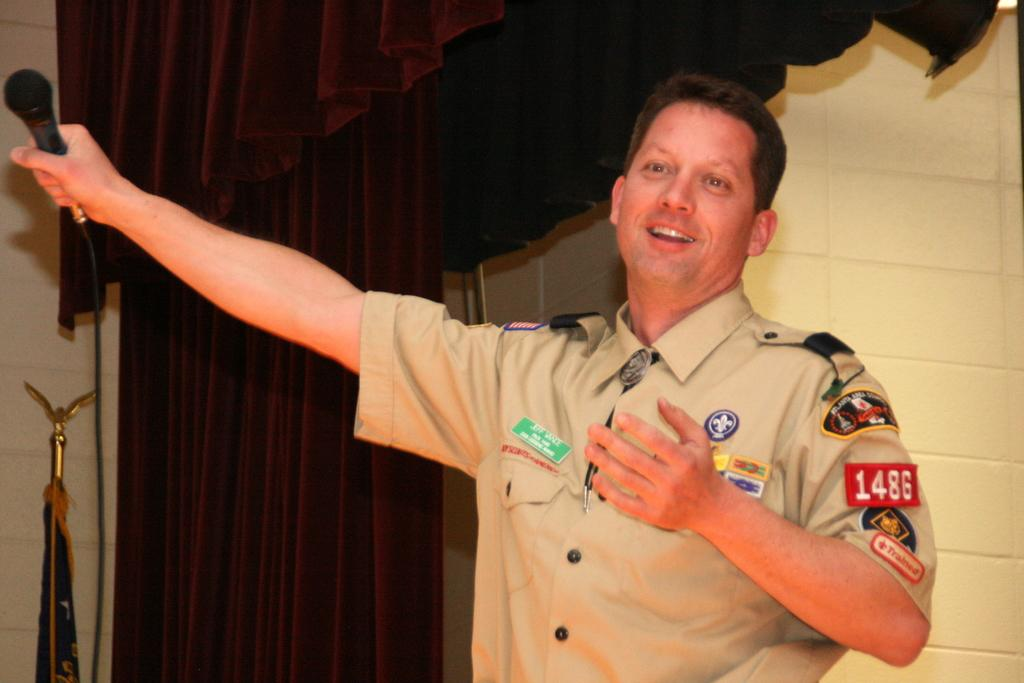What is the person in the image doing? The person is standing in the image and holding a microphone. What is the person's facial expression in the image? The person is smiling in the image. What can be seen in the background of the image? There is a curtain in the background of the image. What is the name of the egg that the person is holding in the image? There is no egg present in the image; the person is holding a microphone. 